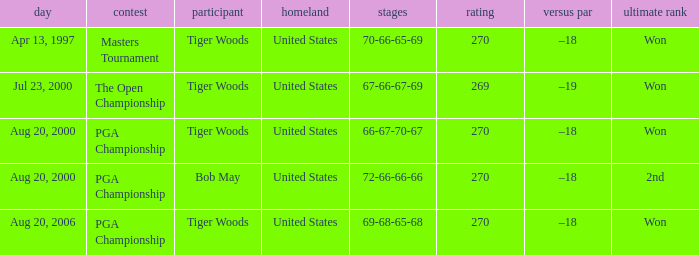What is the worst (highest) score? 270.0. Can you parse all the data within this table? {'header': ['day', 'contest', 'participant', 'homeland', 'stages', 'rating', 'versus par', 'ultimate rank'], 'rows': [['Apr 13, 1997', 'Masters Tournament', 'Tiger Woods', 'United States', '70-66-65-69', '270', '–18', 'Won'], ['Jul 23, 2000', 'The Open Championship', 'Tiger Woods', 'United States', '67-66-67-69', '269', '–19', 'Won'], ['Aug 20, 2000', 'PGA Championship', 'Tiger Woods', 'United States', '66-67-70-67', '270', '–18', 'Won'], ['Aug 20, 2000', 'PGA Championship', 'Bob May', 'United States', '72-66-66-66', '270', '–18', '2nd'], ['Aug 20, 2006', 'PGA Championship', 'Tiger Woods', 'United States', '69-68-65-68', '270', '–18', 'Won']]} 